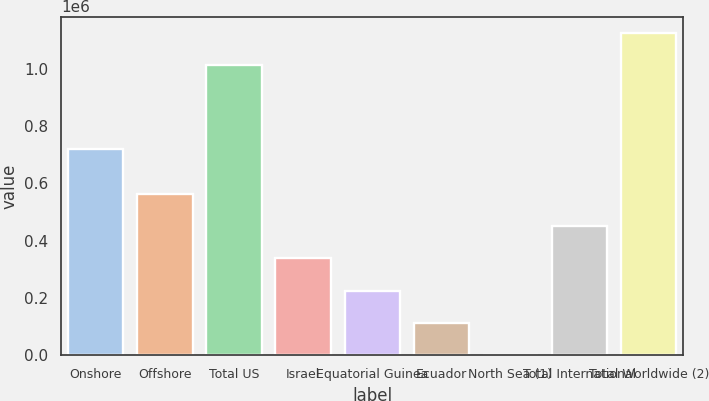<chart> <loc_0><loc_0><loc_500><loc_500><bar_chart><fcel>Onshore<fcel>Offshore<fcel>Total US<fcel>Israel<fcel>Equatorial Guinea<fcel>Ecuador<fcel>North Sea (1)<fcel>Total International<fcel>Total Worldwide (2)<nl><fcel>718997<fcel>562066<fcel>1.01446e+06<fcel>337975<fcel>225929<fcel>113884<fcel>1838<fcel>450021<fcel>1.12651e+06<nl></chart> 